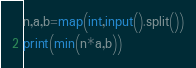<code> <loc_0><loc_0><loc_500><loc_500><_Python_>n,a,b=map(int,input().split())
print(min(n*a,b))</code> 